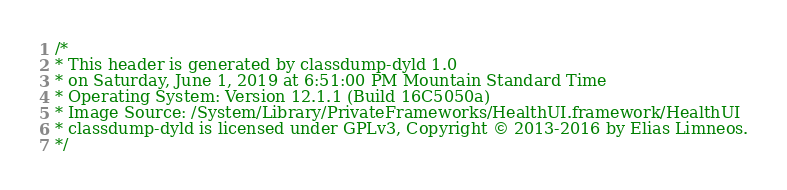Convert code to text. <code><loc_0><loc_0><loc_500><loc_500><_C_>/*
* This header is generated by classdump-dyld 1.0
* on Saturday, June 1, 2019 at 6:51:00 PM Mountain Standard Time
* Operating System: Version 12.1.1 (Build 16C5050a)
* Image Source: /System/Library/PrivateFrameworks/HealthUI.framework/HealthUI
* classdump-dyld is licensed under GPLv3, Copyright © 2013-2016 by Elias Limneos.
*/
</code> 